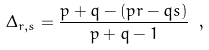<formula> <loc_0><loc_0><loc_500><loc_500>\Delta _ { r , s } = \frac { p + q - ( p r - q s ) } { p + q - 1 } \ ,</formula> 